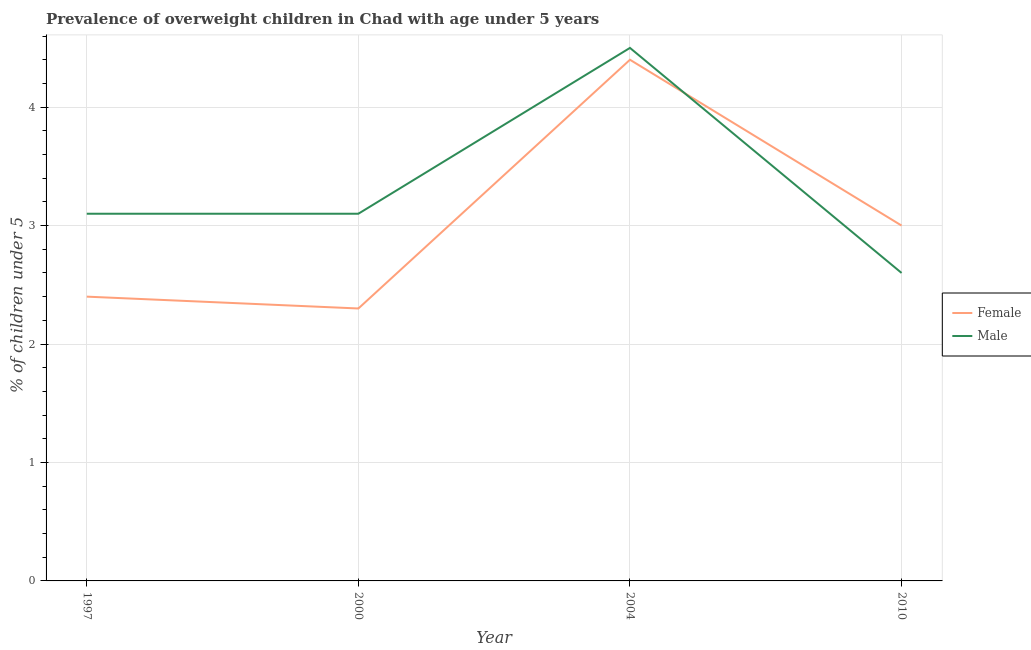Does the line corresponding to percentage of obese female children intersect with the line corresponding to percentage of obese male children?
Your response must be concise. Yes. What is the percentage of obese female children in 2004?
Your answer should be compact. 4.4. Across all years, what is the maximum percentage of obese female children?
Provide a succinct answer. 4.4. Across all years, what is the minimum percentage of obese female children?
Your response must be concise. 2.3. What is the total percentage of obese male children in the graph?
Make the answer very short. 13.3. What is the difference between the percentage of obese female children in 2000 and that in 2004?
Offer a very short reply. -2.1. What is the difference between the percentage of obese female children in 2004 and the percentage of obese male children in 2010?
Provide a succinct answer. 1.8. What is the average percentage of obese male children per year?
Your answer should be compact. 3.32. In the year 1997, what is the difference between the percentage of obese male children and percentage of obese female children?
Give a very brief answer. 0.7. What is the ratio of the percentage of obese female children in 2000 to that in 2010?
Your response must be concise. 0.77. Is the difference between the percentage of obese female children in 1997 and 2000 greater than the difference between the percentage of obese male children in 1997 and 2000?
Provide a succinct answer. Yes. What is the difference between the highest and the second highest percentage of obese male children?
Make the answer very short. 1.4. What is the difference between the highest and the lowest percentage of obese female children?
Your response must be concise. 2.1. In how many years, is the percentage of obese male children greater than the average percentage of obese male children taken over all years?
Provide a short and direct response. 1. Does the percentage of obese female children monotonically increase over the years?
Offer a terse response. No. Is the percentage of obese female children strictly greater than the percentage of obese male children over the years?
Provide a succinct answer. No. Does the graph contain grids?
Offer a very short reply. Yes. How many legend labels are there?
Keep it short and to the point. 2. What is the title of the graph?
Provide a short and direct response. Prevalence of overweight children in Chad with age under 5 years. Does "International Visitors" appear as one of the legend labels in the graph?
Keep it short and to the point. No. What is the label or title of the Y-axis?
Keep it short and to the point.  % of children under 5. What is the  % of children under 5 in Female in 1997?
Offer a very short reply. 2.4. What is the  % of children under 5 of Male in 1997?
Your response must be concise. 3.1. What is the  % of children under 5 in Female in 2000?
Provide a succinct answer. 2.3. What is the  % of children under 5 of Male in 2000?
Your answer should be very brief. 3.1. What is the  % of children under 5 in Female in 2004?
Your answer should be compact. 4.4. What is the  % of children under 5 in Male in 2004?
Your answer should be compact. 4.5. What is the  % of children under 5 in Female in 2010?
Ensure brevity in your answer.  3. What is the  % of children under 5 of Male in 2010?
Offer a terse response. 2.6. Across all years, what is the maximum  % of children under 5 of Female?
Your answer should be very brief. 4.4. Across all years, what is the maximum  % of children under 5 in Male?
Your answer should be very brief. 4.5. Across all years, what is the minimum  % of children under 5 of Female?
Give a very brief answer. 2.3. Across all years, what is the minimum  % of children under 5 in Male?
Your answer should be compact. 2.6. What is the total  % of children under 5 in Female in the graph?
Give a very brief answer. 12.1. What is the difference between the  % of children under 5 of Female in 1997 and that in 2000?
Keep it short and to the point. 0.1. What is the difference between the  % of children under 5 in Female in 1997 and that in 2004?
Ensure brevity in your answer.  -2. What is the difference between the  % of children under 5 in Male in 1997 and that in 2004?
Make the answer very short. -1.4. What is the difference between the  % of children under 5 in Male in 1997 and that in 2010?
Make the answer very short. 0.5. What is the difference between the  % of children under 5 of Female in 2000 and that in 2004?
Make the answer very short. -2.1. What is the difference between the  % of children under 5 in Male in 2000 and that in 2004?
Your answer should be very brief. -1.4. What is the difference between the  % of children under 5 in Female in 2000 and that in 2010?
Give a very brief answer. -0.7. What is the difference between the  % of children under 5 in Male in 2000 and that in 2010?
Provide a short and direct response. 0.5. What is the difference between the  % of children under 5 of Male in 2004 and that in 2010?
Your response must be concise. 1.9. What is the difference between the  % of children under 5 in Female in 2000 and the  % of children under 5 in Male in 2004?
Provide a succinct answer. -2.2. What is the average  % of children under 5 in Female per year?
Your response must be concise. 3.02. What is the average  % of children under 5 of Male per year?
Provide a short and direct response. 3.33. In the year 2000, what is the difference between the  % of children under 5 of Female and  % of children under 5 of Male?
Provide a succinct answer. -0.8. In the year 2010, what is the difference between the  % of children under 5 in Female and  % of children under 5 in Male?
Keep it short and to the point. 0.4. What is the ratio of the  % of children under 5 in Female in 1997 to that in 2000?
Your answer should be compact. 1.04. What is the ratio of the  % of children under 5 in Female in 1997 to that in 2004?
Keep it short and to the point. 0.55. What is the ratio of the  % of children under 5 of Male in 1997 to that in 2004?
Ensure brevity in your answer.  0.69. What is the ratio of the  % of children under 5 of Male in 1997 to that in 2010?
Your answer should be very brief. 1.19. What is the ratio of the  % of children under 5 in Female in 2000 to that in 2004?
Your answer should be very brief. 0.52. What is the ratio of the  % of children under 5 of Male in 2000 to that in 2004?
Offer a terse response. 0.69. What is the ratio of the  % of children under 5 in Female in 2000 to that in 2010?
Provide a short and direct response. 0.77. What is the ratio of the  % of children under 5 in Male in 2000 to that in 2010?
Provide a short and direct response. 1.19. What is the ratio of the  % of children under 5 of Female in 2004 to that in 2010?
Offer a very short reply. 1.47. What is the ratio of the  % of children under 5 of Male in 2004 to that in 2010?
Give a very brief answer. 1.73. What is the difference between the highest and the second highest  % of children under 5 in Female?
Provide a succinct answer. 1.4. What is the difference between the highest and the second highest  % of children under 5 of Male?
Make the answer very short. 1.4. What is the difference between the highest and the lowest  % of children under 5 in Male?
Your response must be concise. 1.9. 